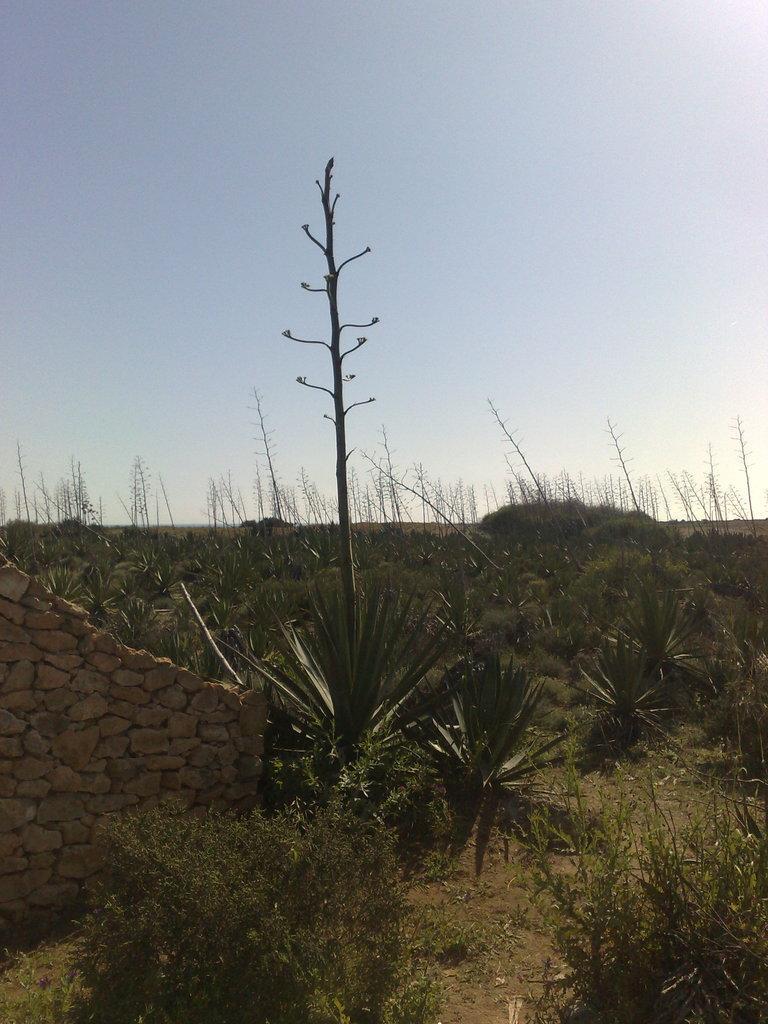How would you summarize this image in a sentence or two? In the picture we can see a surface with plants and beside it, we can see a wall made up of rocks and behind it, we can see some plants and in the background we can see the sky. 